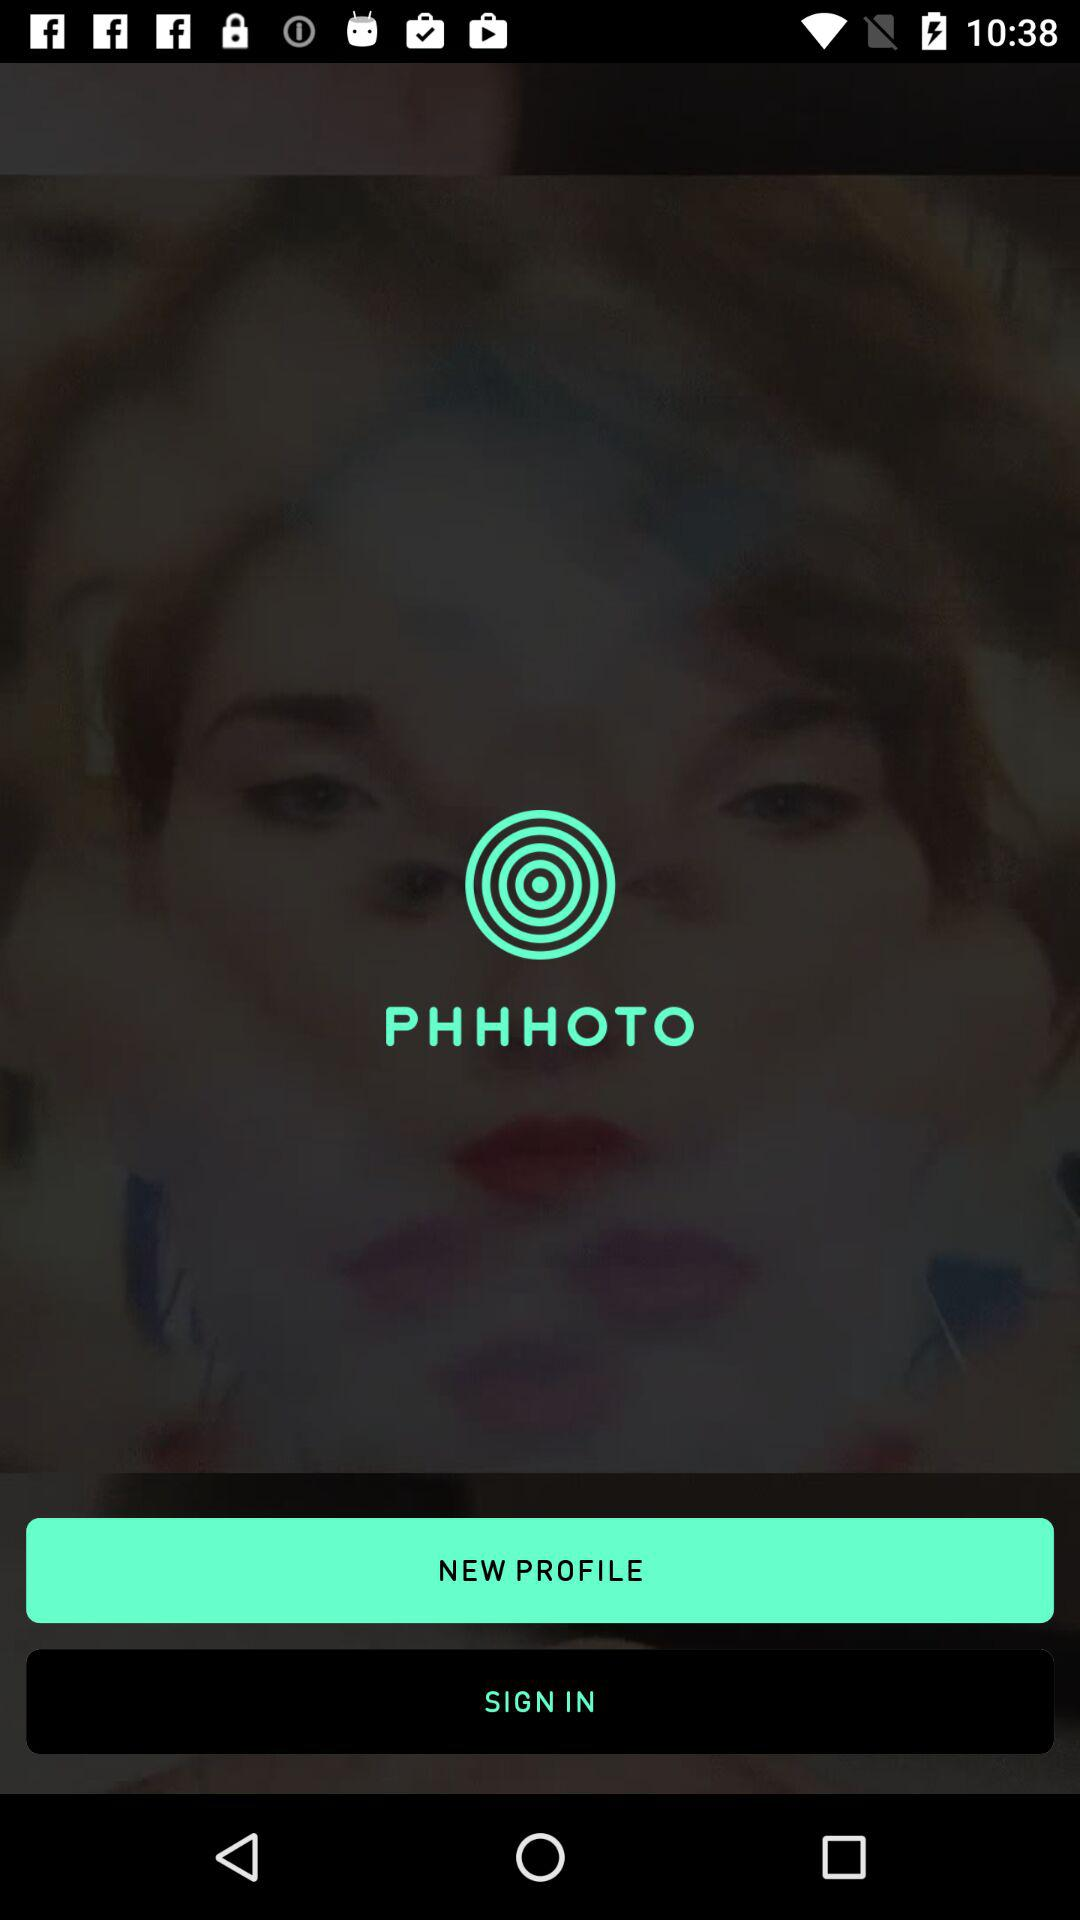What is the name of the application? The name of the application is "PHHHOTO". 